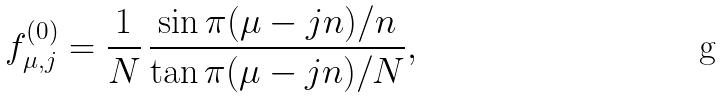<formula> <loc_0><loc_0><loc_500><loc_500>f ^ { ( 0 ) } _ { \mu , j } = \frac { 1 } { N } \, \frac { \sin { \pi ( \mu - j n ) / n } } { \tan { \pi ( \mu - j n ) / N } } ,</formula> 